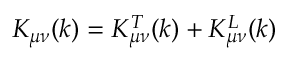<formula> <loc_0><loc_0><loc_500><loc_500>K _ { \mu \nu } ( k ) = K _ { \mu \nu } ^ { T } ( k ) + K _ { \mu \nu } ^ { L } ( k )</formula> 